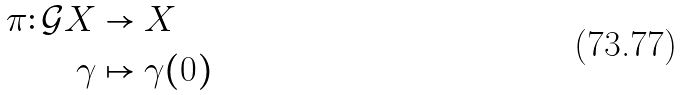Convert formula to latex. <formula><loc_0><loc_0><loc_500><loc_500>\pi \colon \mathcal { G } X & \to X \\ \gamma & \mapsto \gamma ( 0 ) \\</formula> 